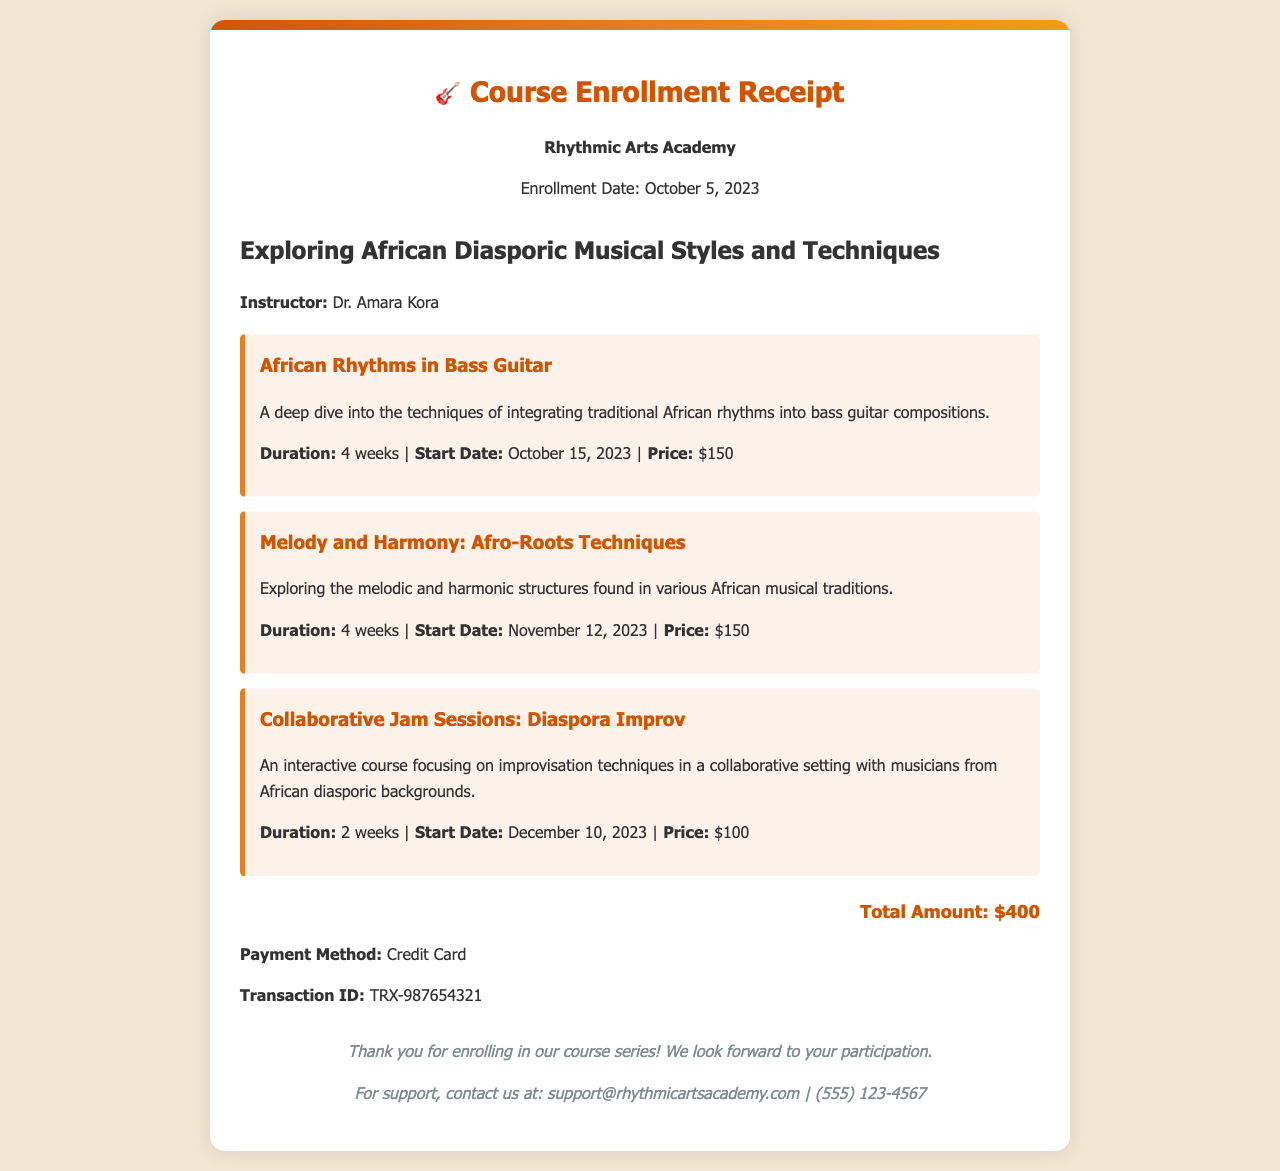What is the name of the instructor? The name of the instructor is provided under the course information section.
Answer: Dr. Amara Kora When does the course "African Rhythms in Bass Guitar" start? The start date for this course is specified clearly in the course details.
Answer: October 15, 2023 What is the total amount for the courses? The total amount is summarized at the bottom of the receipt.
Answer: $400 What is the duration of the "Collaborative Jam Sessions: Diaspora Improv" course? The document specifies the duration for each course in the details.
Answer: 2 weeks How is the payment made? The payment method is mentioned in the payment information section of the receipt.
Answer: Credit Card What is the transaction ID for the enrollment? The transaction ID is clearly displayed in the payment information section.
Answer: TRX-987654321 How many courses are included in this series? The number of courses can be determined by counting the individual course sections listed in the document.
Answer: 3 What is the price of the course titled "Melody and Harmony: Afro-Roots Techniques"? The price for this specific course is specified in its details.
Answer: $150 What is the contact number for support? The contact details are provided at the end of the receipt.
Answer: (555) 123-4567 